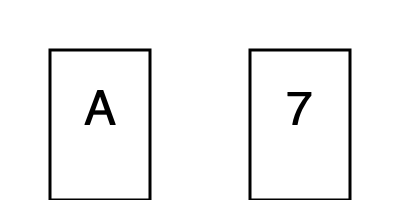In the Wason selection task, participants are presented with four cards, as shown above, and are given a rule: "If a card has a vowel on one side, then it has an even number on the other side." Which card(s) must be turned over to test this rule, and how does this task reveal biases in human reasoning? 1. The Wason selection task is designed to test conditional reasoning abilities.

2. The correct cards to turn over are:
   a) The 'A' card: To check if it has an even number on the other side.
   b) The '7' card: To ensure it doesn't have a vowel on the other side.

3. Most people correctly choose the 'A' card but fail to select the '7' card.

4. This reveals confirmation bias: People tend to look for evidence that confirms the rule rather than trying to falsify it.

5. It also shows matching bias: People are drawn to cards mentioned in the rule (vowels and even numbers) rather than considering all logical possibilities.

6. From a logical standpoint, the rule is only falsified if a vowel is paired with an odd number. The '7' card is crucial for this.

7. This task demonstrates that humans often use heuristics rather than formal logic in reasoning, which can lead to systematic errors.

8. The discrepancy between normative logical reasoning and actual human performance suggests that our cognitive architecture may not be optimized for abstract logical tasks.

9. This has implications for theories of rationality and the evolution of human reasoning capacities, suggesting that our reasoning might be more adapted to real-world, ecologically valid scenarios than abstract logical problems.
Answer: Turn over 'A' and '7' cards; reveals confirmation and matching biases in human reasoning. 